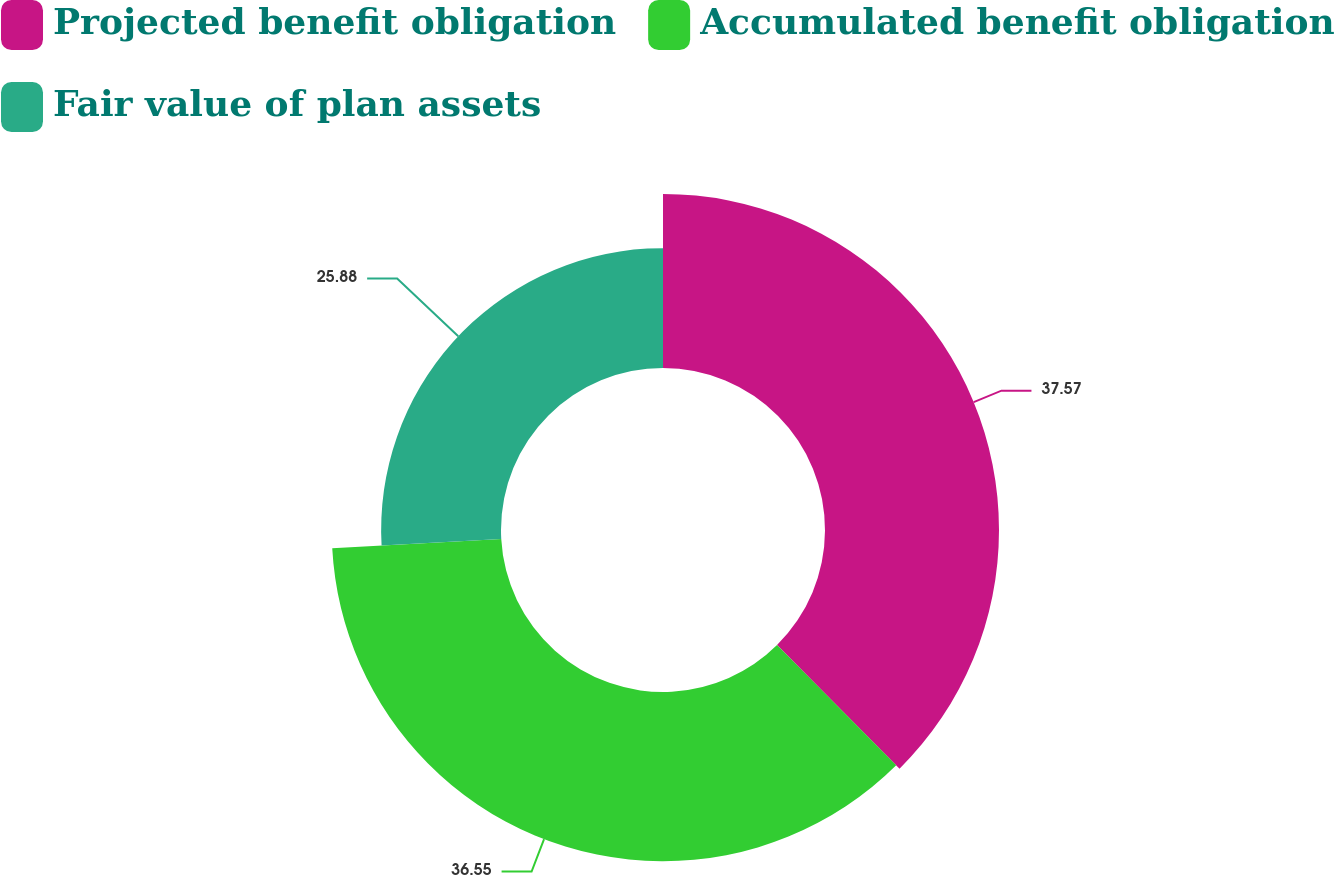Convert chart. <chart><loc_0><loc_0><loc_500><loc_500><pie_chart><fcel>Projected benefit obligation<fcel>Accumulated benefit obligation<fcel>Fair value of plan assets<nl><fcel>37.57%<fcel>36.55%<fcel>25.88%<nl></chart> 